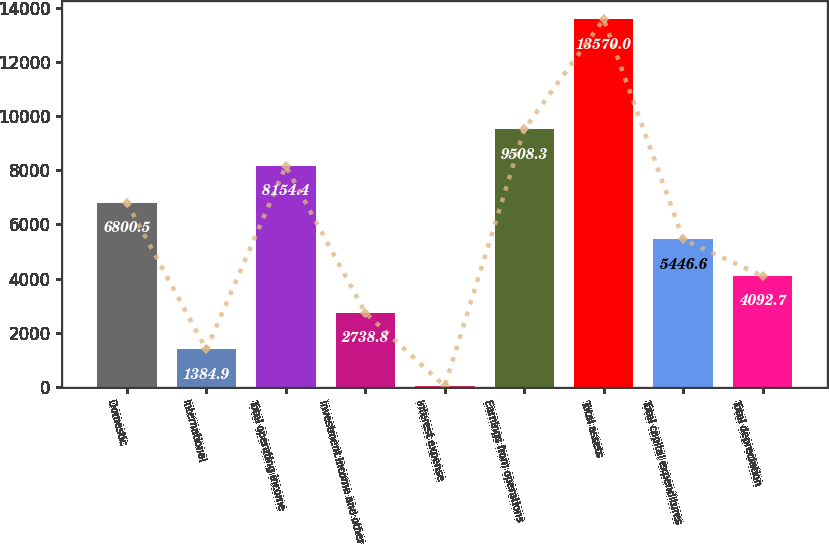<chart> <loc_0><loc_0><loc_500><loc_500><bar_chart><fcel>Domestic<fcel>International<fcel>Total operating income<fcel>Investment income and other<fcel>Interest expense<fcel>Earnings from operations<fcel>Total assets<fcel>Total capital expenditures<fcel>Total depreciation<nl><fcel>6800.5<fcel>1384.9<fcel>8154.4<fcel>2738.8<fcel>31<fcel>9508.3<fcel>13570<fcel>5446.6<fcel>4092.7<nl></chart> 